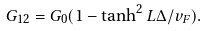Convert formula to latex. <formula><loc_0><loc_0><loc_500><loc_500>G _ { 1 2 } = G _ { 0 } ( 1 - \tanh ^ { 2 } L \Delta / v _ { F } ) .</formula> 